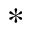Convert formula to latex. <formula><loc_0><loc_0><loc_500><loc_500>^ { * }</formula> 